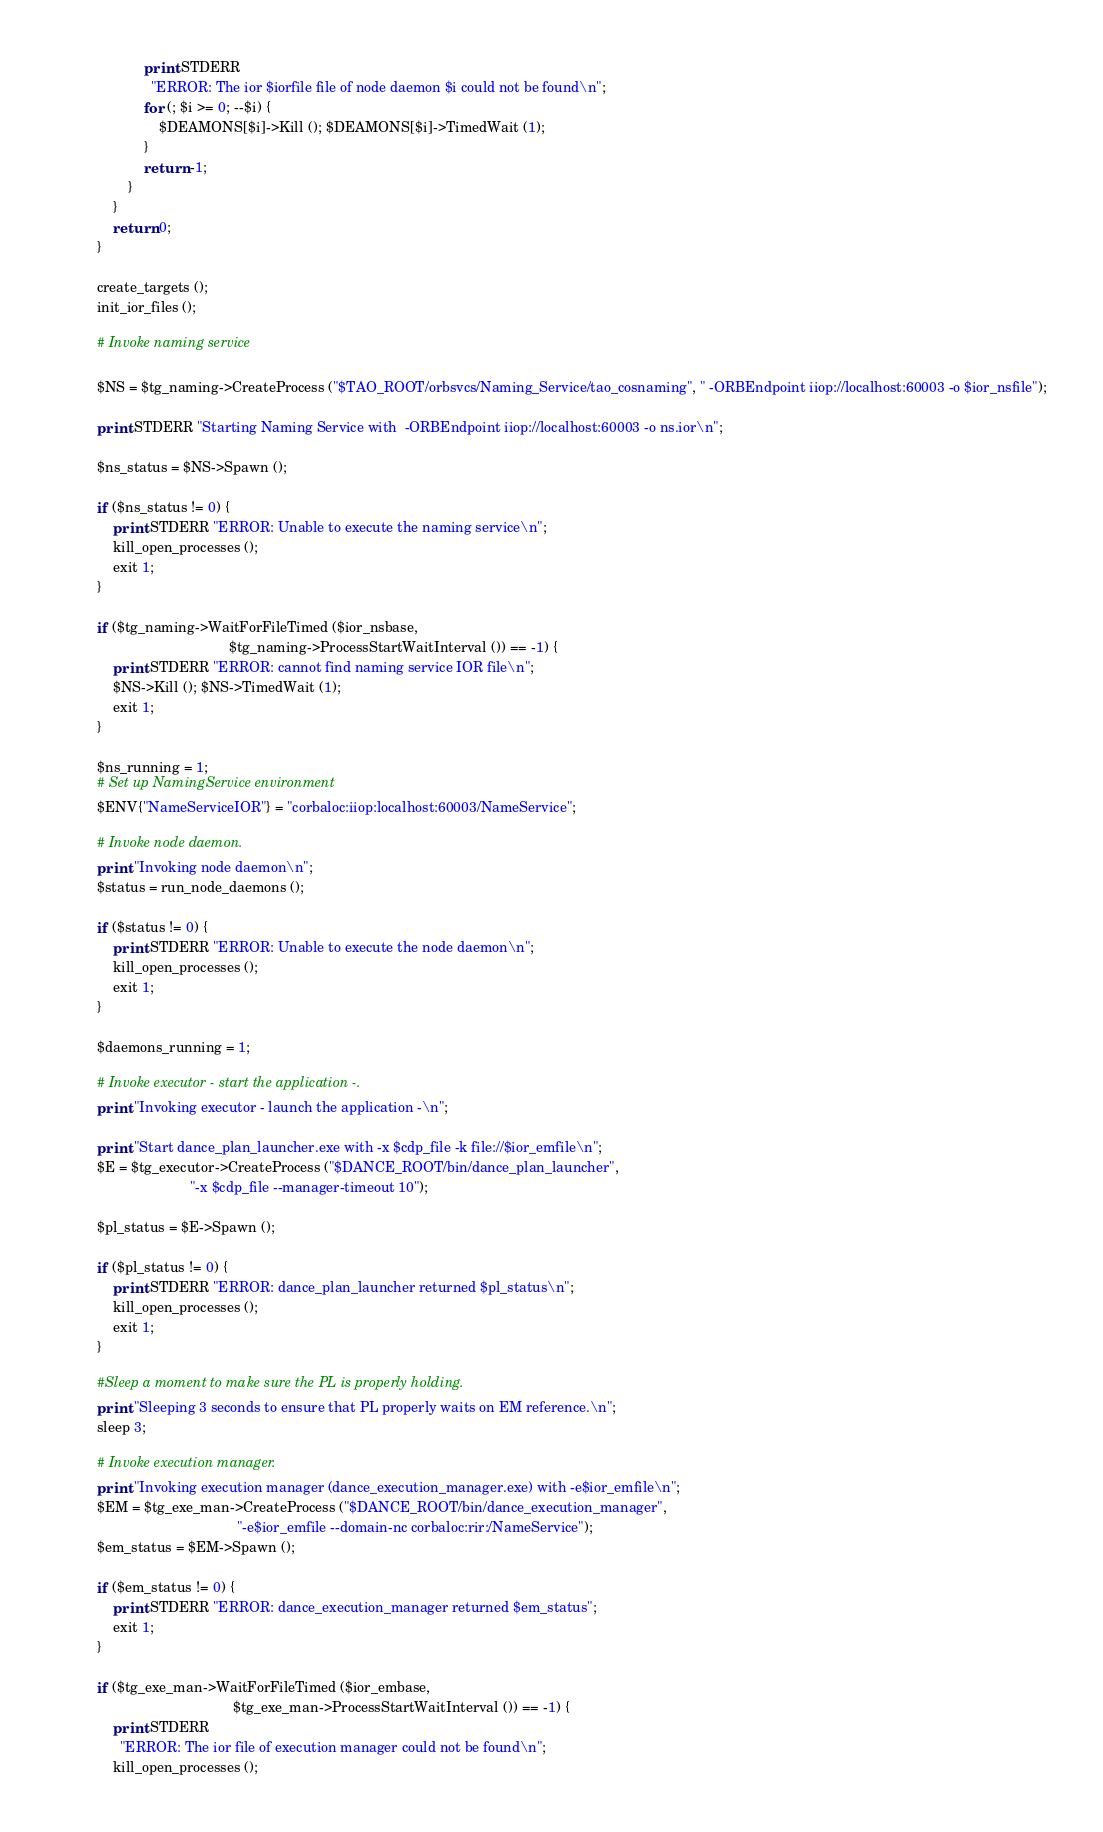<code> <loc_0><loc_0><loc_500><loc_500><_Perl_>            print STDERR
              "ERROR: The ior $iorfile file of node daemon $i could not be found\n";
            for (; $i >= 0; --$i) {
                $DEAMONS[$i]->Kill (); $DEAMONS[$i]->TimedWait (1);
            }
            return -1;
        }
    }
    return 0;
}

create_targets ();
init_ior_files ();

# Invoke naming service

$NS = $tg_naming->CreateProcess ("$TAO_ROOT/orbsvcs/Naming_Service/tao_cosnaming", " -ORBEndpoint iiop://localhost:60003 -o $ior_nsfile");

print STDERR "Starting Naming Service with  -ORBEndpoint iiop://localhost:60003 -o ns.ior\n";

$ns_status = $NS->Spawn ();

if ($ns_status != 0) {
    print STDERR "ERROR: Unable to execute the naming service\n";
    kill_open_processes ();
    exit 1;
}

if ($tg_naming->WaitForFileTimed ($ior_nsbase,
                                  $tg_naming->ProcessStartWaitInterval ()) == -1) {
    print STDERR "ERROR: cannot find naming service IOR file\n";
    $NS->Kill (); $NS->TimedWait (1);
    exit 1;
}

$ns_running = 1;
# Set up NamingService environment
$ENV{"NameServiceIOR"} = "corbaloc:iiop:localhost:60003/NameService";

# Invoke node daemon.
print "Invoking node daemon\n";
$status = run_node_daemons ();

if ($status != 0) {
    print STDERR "ERROR: Unable to execute the node daemon\n";
    kill_open_processes ();
    exit 1;
}

$daemons_running = 1;

# Invoke executor - start the application -.
print "Invoking executor - launch the application -\n";

print "Start dance_plan_launcher.exe with -x $cdp_file -k file://$ior_emfile\n";
$E = $tg_executor->CreateProcess ("$DANCE_ROOT/bin/dance_plan_launcher",
                        "-x $cdp_file --manager-timeout 10");

$pl_status = $E->Spawn ();

if ($pl_status != 0) {
    print STDERR "ERROR: dance_plan_launcher returned $pl_status\n";
    kill_open_processes ();
    exit 1;
}

#Sleep a moment to make sure the PL is properly holding.
print "Sleeping 3 seconds to ensure that PL properly waits on EM reference.\n";
sleep 3;

# Invoke execution manager.
print "Invoking execution manager (dance_execution_manager.exe) with -e$ior_emfile\n";
$EM = $tg_exe_man->CreateProcess ("$DANCE_ROOT/bin/dance_execution_manager",
                                    "-e$ior_emfile --domain-nc corbaloc:rir:/NameService");
$em_status = $EM->Spawn ();

if ($em_status != 0) {
    print STDERR "ERROR: dance_execution_manager returned $em_status";
    exit 1;
}

if ($tg_exe_man->WaitForFileTimed ($ior_embase,
                                   $tg_exe_man->ProcessStartWaitInterval ()) == -1) {
    print STDERR
      "ERROR: The ior file of execution manager could not be found\n";
    kill_open_processes ();</code> 